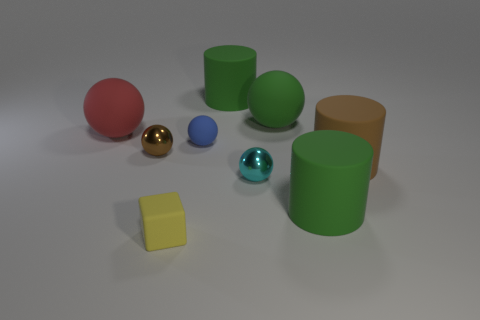Do the big green cylinder that is in front of the tiny rubber sphere and the brown cylinder right of the blue matte thing have the same material?
Ensure brevity in your answer.  Yes. What is the material of the tiny yellow thing that is in front of the small matte thing that is right of the tiny yellow rubber cube?
Make the answer very short. Rubber. What shape is the brown thing that is on the right side of the green rubber cylinder that is left of the shiny sphere that is on the right side of the yellow rubber cube?
Give a very brief answer. Cylinder. What is the material of the red thing that is the same shape as the blue rubber object?
Provide a succinct answer. Rubber. What number of tiny metal balls are there?
Your answer should be very brief. 2. There is a large green object left of the green rubber ball; what shape is it?
Give a very brief answer. Cylinder. What is the color of the tiny metallic ball that is right of the brown object left of the small cyan sphere that is in front of the brown rubber thing?
Give a very brief answer. Cyan. What is the shape of the large red thing that is the same material as the cube?
Keep it short and to the point. Sphere. Is the number of large red spheres less than the number of big cyan matte cylinders?
Keep it short and to the point. No. Is the material of the tiny cyan object the same as the blue thing?
Keep it short and to the point. No. 